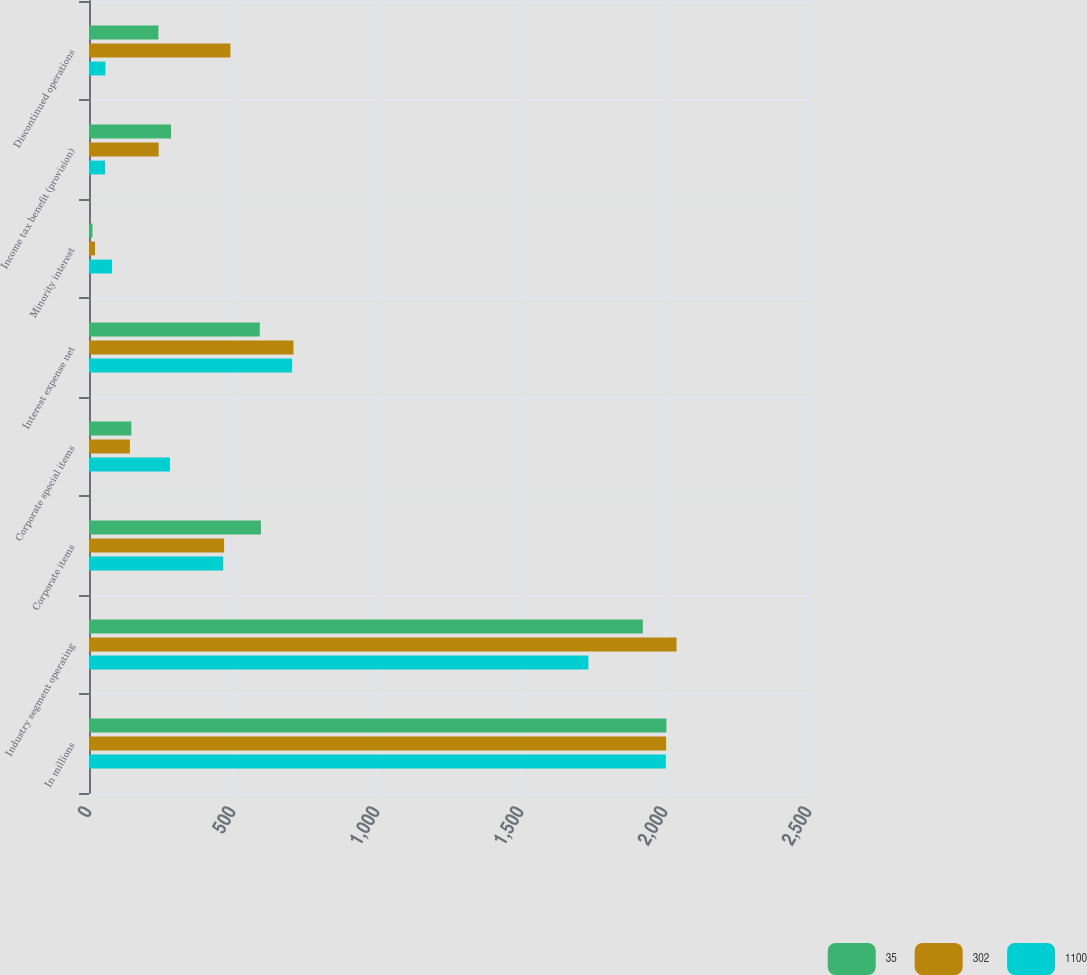Convert chart. <chart><loc_0><loc_0><loc_500><loc_500><stacked_bar_chart><ecel><fcel>In millions<fcel>Industry segment operating<fcel>Corporate items<fcel>Corporate special items<fcel>Interest expense net<fcel>Minority interest<fcel>Income tax benefit (provision)<fcel>Discontinued operations<nl><fcel>35<fcel>2005<fcel>1923<fcel>597<fcel>147<fcel>593<fcel>12<fcel>285<fcel>241<nl><fcel>302<fcel>2004<fcel>2040<fcel>469<fcel>142<fcel>710<fcel>21<fcel>242<fcel>491<nl><fcel>1100<fcel>2003<fcel>1734<fcel>466<fcel>281<fcel>705<fcel>80<fcel>56<fcel>57<nl></chart> 